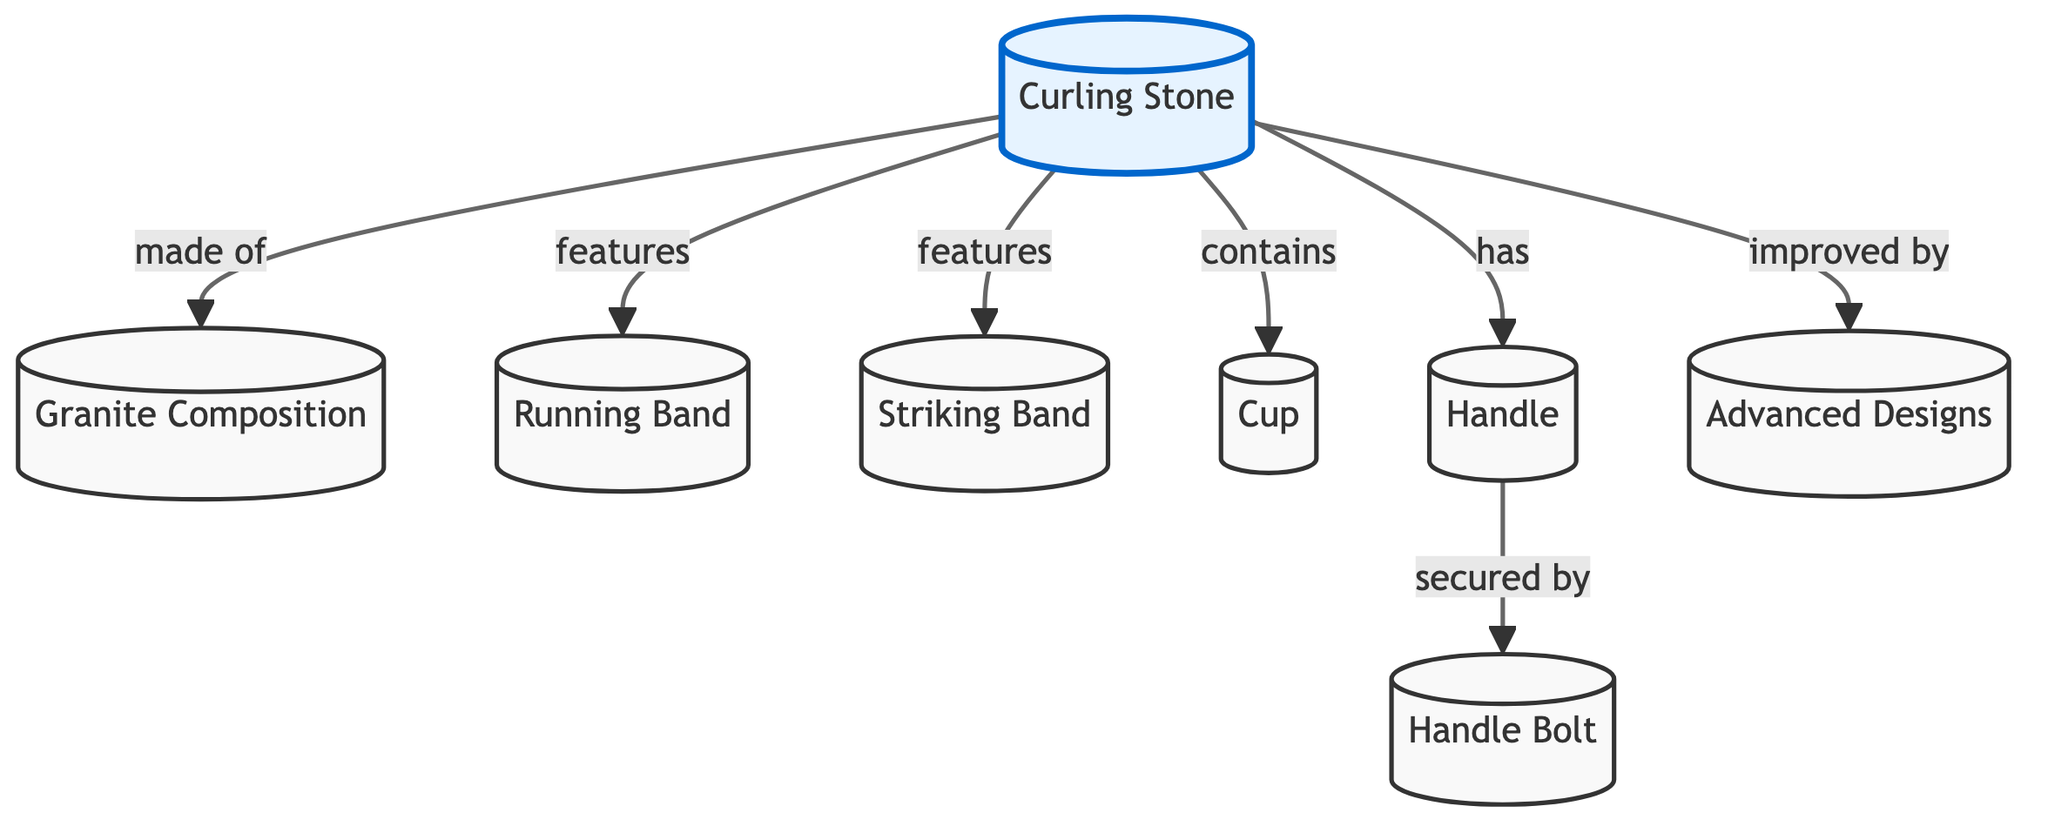What is the main component of a curling stone? The diagram indicates that the main component of a curling stone is "Granite Composition," clearly labeled as the first connection from the "Curling Stone" node.
Answer: Granite Composition How many features does the curling stone have? The diagram shows that there are three features connected to the "Curling Stone" node: "Running Band," "Striking Band," and "Handle." Thus, there are three features.
Answer: Three What is the purpose of the handle in the curling stone? The diagram establishes that the handle is a part of the curling stone that is "secured by Handle Bolt," which implies that the handle plays a role in providing grip for the player.
Answer: Grip What materials improve the curling stone's design? The diagram specifies "Advanced Designs" as the aspect that improves the curling stone, indicating that these designs incorporate specific materials or methods enhancing performance.
Answer: Advanced Designs What part of the curling stone is in contact with the ice? The diagram indicates that the "Running Band" is a feature of the curling stone, which suggests that this is the part that typically makes contact with the ice during play.
Answer: Running Band What do the terms “Running Band” and “Striking Band” refer to? Both terms are features of the curling stone showing that "Running Band" relates to movement across the ice while "Striking Band" may pertain to its contact aspect during gameplay, suggesting their functional roles in performance.
Answer: Features of the stone What connects the handle to the curling stone? The diagram shows that the "Handle Bolt" is the component that secures the "Handle," indicating the connecting mechanism for these parts.
Answer: Handle Bolt Which component enhances performance through design? The diagram states that the "Advanced Designs" improve the curling stone, highlighting the innovative aspects that contribute to better game efficiency or play quality.
Answer: Advanced Designs What does the term “Cup” refer to in the curling stone? The diagram illustrates that "Cup" is a part of the curling stone but does not specify its role; however, it implies a functional aspect, possibly linked to balance or weight distribution within the stone.
Answer: Part of the stone 